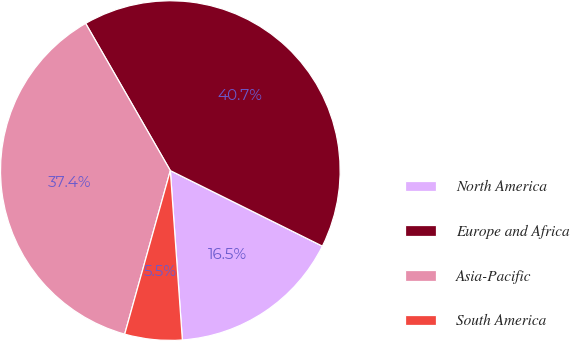<chart> <loc_0><loc_0><loc_500><loc_500><pie_chart><fcel>North America<fcel>Europe and Africa<fcel>Asia-Pacific<fcel>South America<nl><fcel>16.53%<fcel>40.65%<fcel>37.36%<fcel>5.46%<nl></chart> 